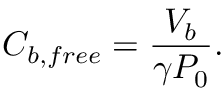<formula> <loc_0><loc_0><loc_500><loc_500>C _ { b , f r e e } = \frac { V _ { b } } { \gamma P _ { 0 } } .</formula> 